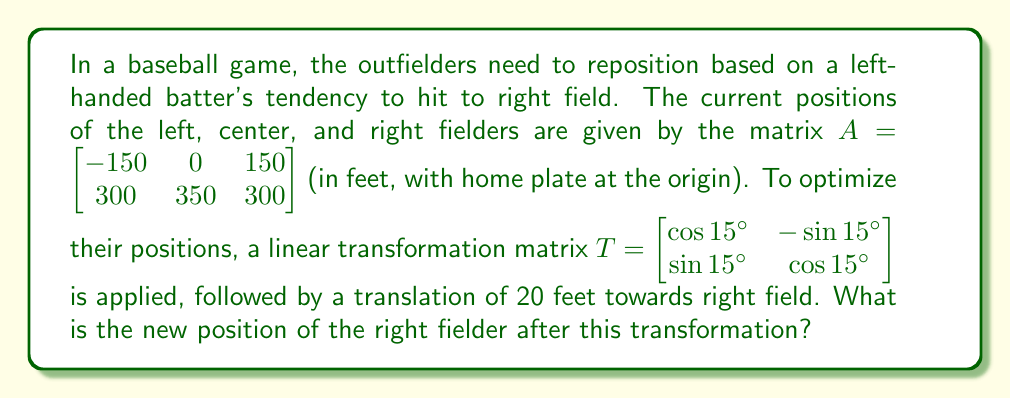What is the answer to this math problem? Let's approach this step-by-step:

1) First, we need to apply the rotation transformation to the original positions. This is done by multiplying the transformation matrix $T$ with matrix $A$:

   $TA = \begin{bmatrix} \cos 15° & -\sin 15° \\ \sin 15° & \cos 15° \end{bmatrix} \begin{bmatrix} -150 & 0 & 150 \\ 300 & 350 & 300 \end{bmatrix}$

2) Let's calculate the values for $\cos 15°$ and $\sin 15°$:
   $\cos 15° \approx 0.9659$ and $\sin 15° \approx 0.2588$

3) Now we can perform the matrix multiplication:

   $TA = \begin{bmatrix} 
   0.9659(-150) + (-0.2588)(300) & 0.9659(0) + (-0.2588)(350) & 0.9659(150) + (-0.2588)(300) \\
   0.2588(-150) + 0.9659(300) & 0.2588(0) + 0.9659(350) & 0.2588(150) + 0.9659(300)
   \end{bmatrix}$

4) Simplifying:

   $TA = \begin{bmatrix} 
   -144.885 - 77.64 & -90.58 & 144.885 - 77.64 \\
   -38.82 + 289.77 & 337.065 & 38.82 + 289.77
   \end{bmatrix}$

   $TA = \begin{bmatrix} 
   -222.525 & -90.58 & 67.245 \\
   250.95 & 337.065 & 328.59
   \end{bmatrix}$

5) The right fielder's position after rotation is the third column: $(67.245, 328.59)$

6) Now we need to apply the translation of 20 feet towards right field. This means adding 20 to the x-coordinate:

   New position = $(67.245 + 20, 328.59) = (87.245, 328.59)$

Therefore, the new position of the right fielder after the transformation is $(87.245, 328.59)$ feet from home plate.
Answer: $(87.245, 328.59)$ feet 